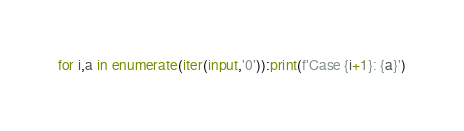<code> <loc_0><loc_0><loc_500><loc_500><_Python_>for i,a in enumerate(iter(input,'0')):print(f'Case {i+1}: {a}')
</code> 